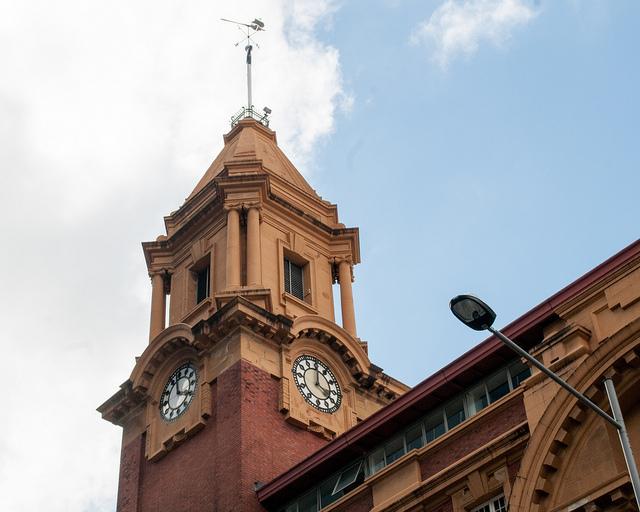Do both of the clocks display the same time?
Answer briefly. Yes. Is it before noon?
Concise answer only. No. Where in the world is this cupola located?
Be succinct. Europe. Is it going to rain?
Concise answer only. No. Is there a tower on the building?
Give a very brief answer. Yes. 